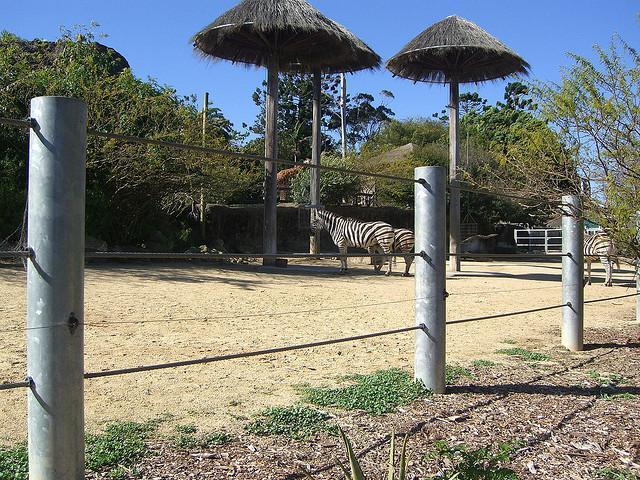How many people are wearing pink shirt?
Give a very brief answer. 0. 